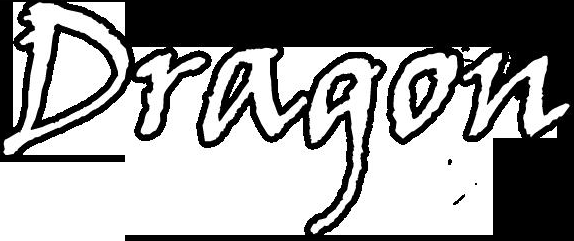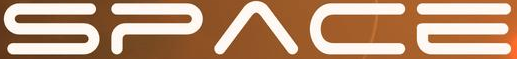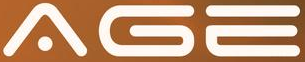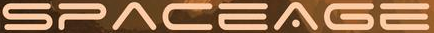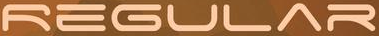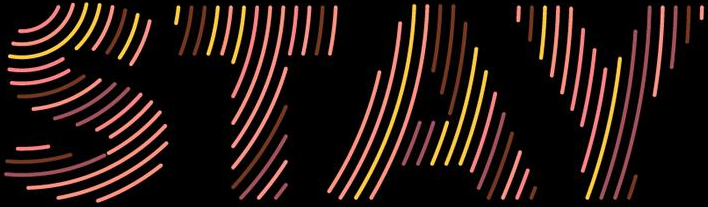What text appears in these images from left to right, separated by a semicolon? Dragon; SPACE; AGE; SPACEAGE; REGULAR; STAY 